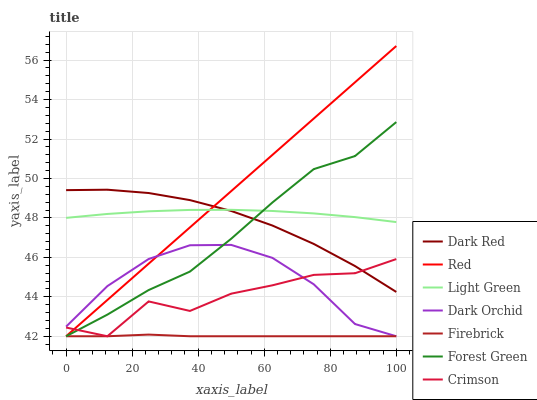Does Firebrick have the minimum area under the curve?
Answer yes or no. Yes. Does Red have the maximum area under the curve?
Answer yes or no. Yes. Does Dark Orchid have the minimum area under the curve?
Answer yes or no. No. Does Dark Orchid have the maximum area under the curve?
Answer yes or no. No. Is Red the smoothest?
Answer yes or no. Yes. Is Crimson the roughest?
Answer yes or no. Yes. Is Firebrick the smoothest?
Answer yes or no. No. Is Firebrick the roughest?
Answer yes or no. No. Does Firebrick have the lowest value?
Answer yes or no. Yes. Does Light Green have the lowest value?
Answer yes or no. No. Does Red have the highest value?
Answer yes or no. Yes. Does Dark Orchid have the highest value?
Answer yes or no. No. Is Firebrick less than Light Green?
Answer yes or no. Yes. Is Light Green greater than Firebrick?
Answer yes or no. Yes. Does Crimson intersect Dark Orchid?
Answer yes or no. Yes. Is Crimson less than Dark Orchid?
Answer yes or no. No. Is Crimson greater than Dark Orchid?
Answer yes or no. No. Does Firebrick intersect Light Green?
Answer yes or no. No. 